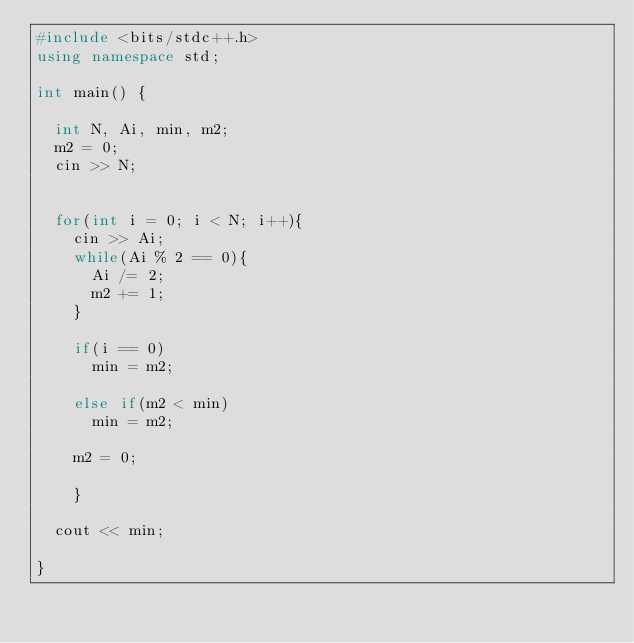<code> <loc_0><loc_0><loc_500><loc_500><_C++_>#include <bits/stdc++.h>
using namespace std;

int main() {

  int N, Ai, min, m2;
  m2 = 0;
  cin >> N;
  

  for(int i = 0; i < N; i++){
    cin >> Ai;
    while(Ai % 2 == 0){
      Ai /= 2;
      m2 += 1;
    }
    
    if(i == 0)
      min = m2;

    else if(m2 < min)
      min = m2;
    
    m2 = 0;

    }

  cout << min;

}</code> 